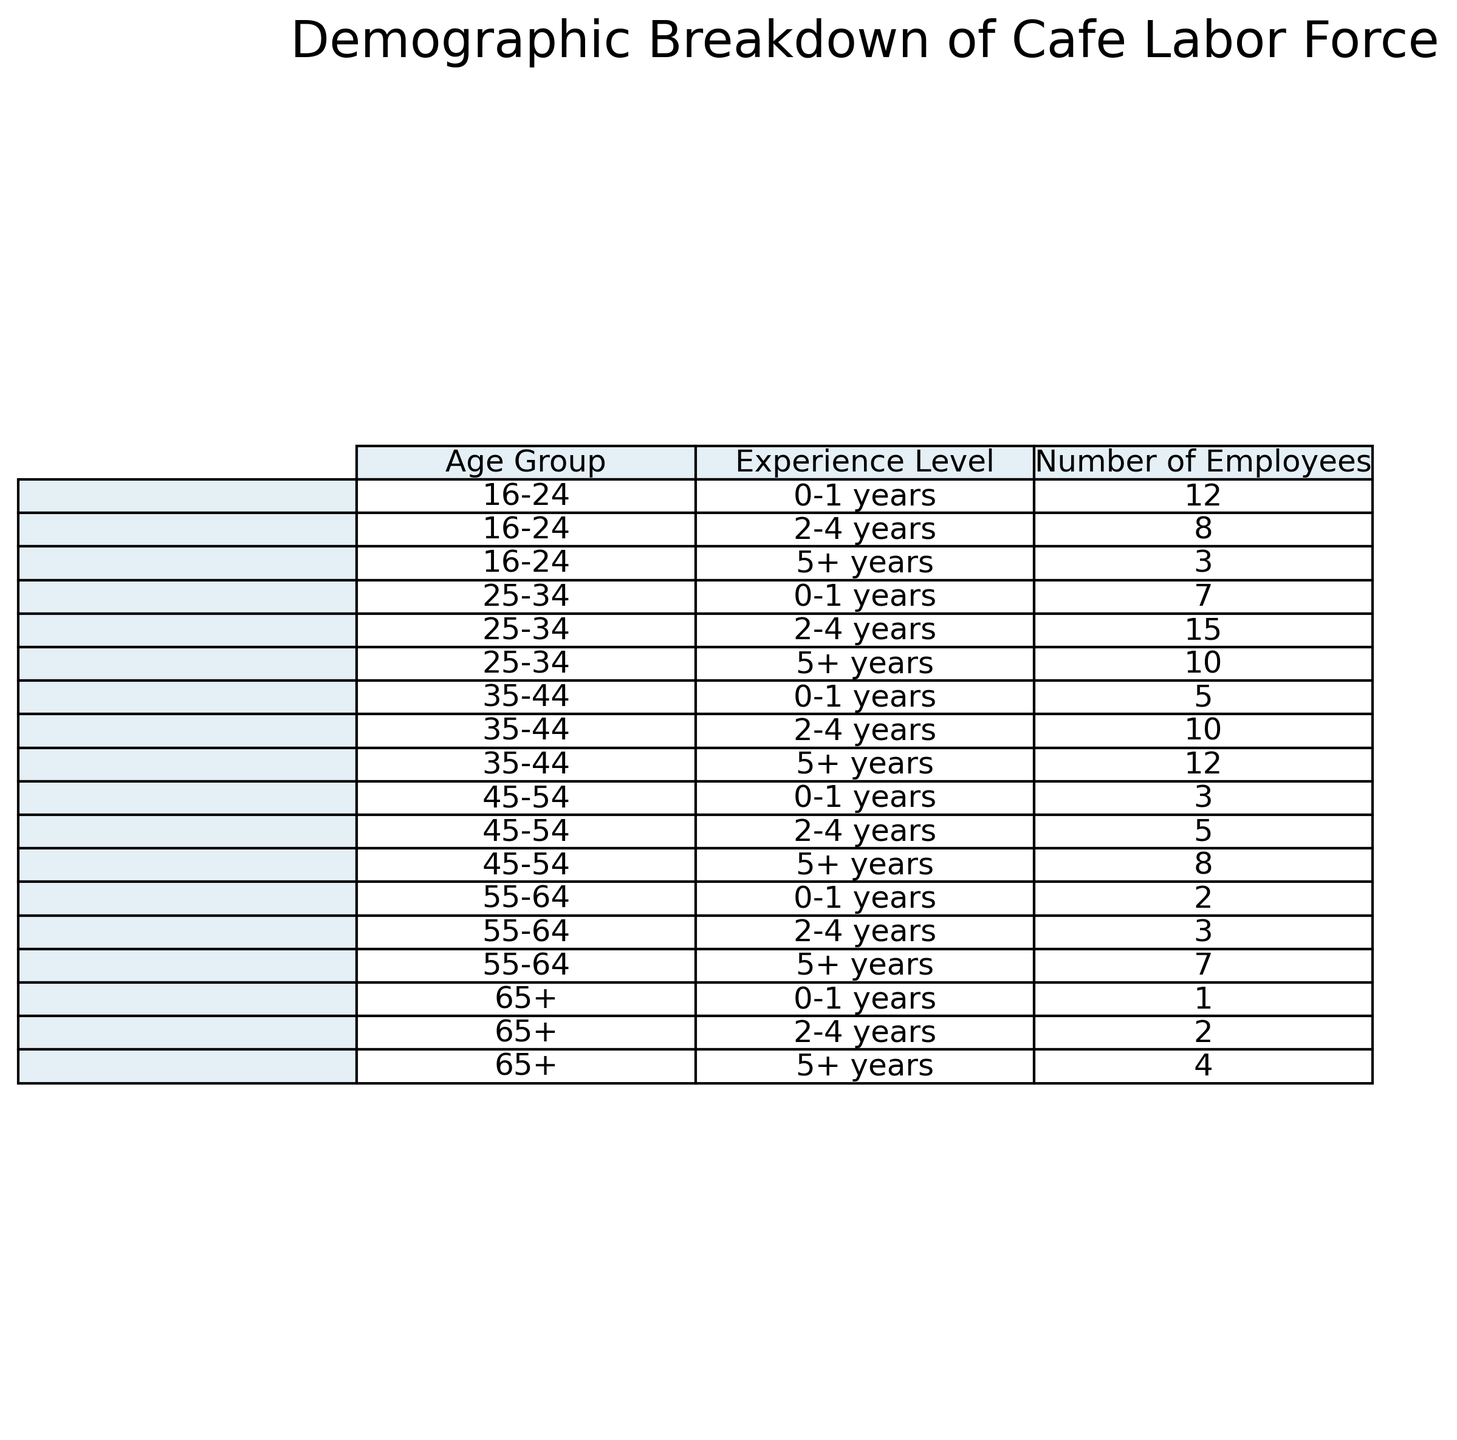What age group has the highest number of employees with 5+ years of experience? Look at the "5+ years" column and identify the age group with the largest value. The age group 35-44 has 12 employees with 5+ years of experience, which is the highest in that column.
Answer: 35-44 Which age group has the least total number of employees? Sum the employee numbers for each age group across all experience levels and compare. The age group 65+ has the least total with 7 employees (1+2+4).
Answer: 65+ What is the total number of employees with 0-1 years of experience? Sum the number of employees in the "0-1 years" column across all age groups: 12+7+5+3+2+1 = 30 employees.
Answer: 30 Which experience level has the most employees in the age group 25-34? Look at the numbers for the age group 25-34 across all experience levels. The highest is 2-4 years with 15 employees.
Answer: 2-4 years How does the number of employees aged 45-54 compare between 0-1 years and 5+ years of experience? For 45-54 age group, compare the values in "0-1 years" (3) and "5+ years" (8) columns. 8 is greater than 3.
Answer: 5+ years is more What is the average number of employees in the 16-24 age group across all experience levels? Sum the numbers for 16-24 age group and divide by 3: (12+8+3)/3 = 23/3 = 7.67 employees.
Answer: 7.67 How many employees are there in the cafe aged 35-54 with 2-4 years of experience? Sum the employees in the 35-44 and 45-54 age groups for 2-4 years of experience: 10 (35-44) + 5 (45-54) = 15 employees.
Answer: 15 Which age group has a greater number of employees with 2-4 years of experience: 35-44 or 55-64? Look at the "2-4 years" column for both age groups. 35-44 has 10 employees while 55-64 has 3 employees. Therefore, 35-44 has more.
Answer: 35-44 What is the difference in the number of employees with 5+ years of experience between the age groups 16-24 and 55-64? Subtract the number of 5+ years employees in 55-64 from that in 16-24: 7 - 3 = 4 employees.
Answer: 4 